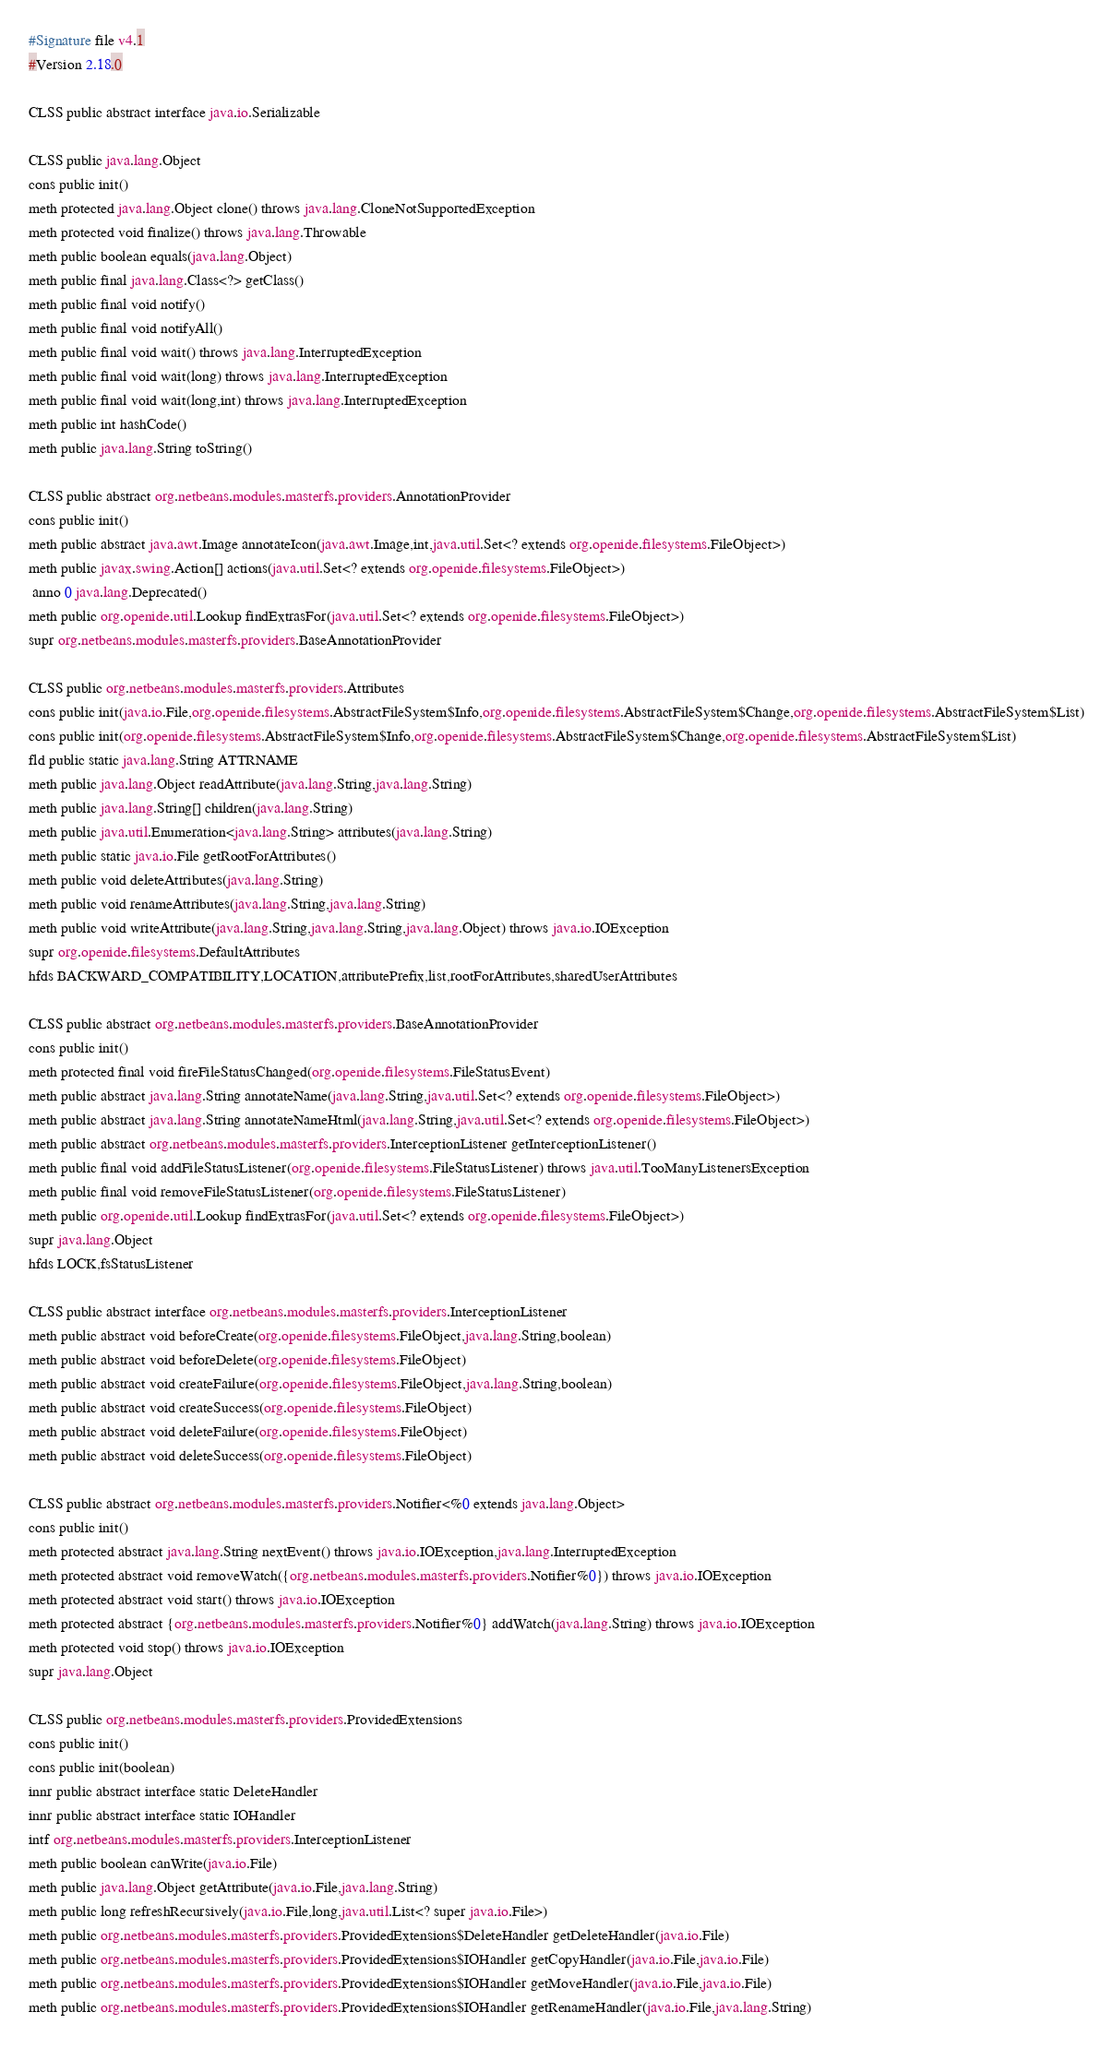<code> <loc_0><loc_0><loc_500><loc_500><_SML_>#Signature file v4.1
#Version 2.18.0

CLSS public abstract interface java.io.Serializable

CLSS public java.lang.Object
cons public init()
meth protected java.lang.Object clone() throws java.lang.CloneNotSupportedException
meth protected void finalize() throws java.lang.Throwable
meth public boolean equals(java.lang.Object)
meth public final java.lang.Class<?> getClass()
meth public final void notify()
meth public final void notifyAll()
meth public final void wait() throws java.lang.InterruptedException
meth public final void wait(long) throws java.lang.InterruptedException
meth public final void wait(long,int) throws java.lang.InterruptedException
meth public int hashCode()
meth public java.lang.String toString()

CLSS public abstract org.netbeans.modules.masterfs.providers.AnnotationProvider
cons public init()
meth public abstract java.awt.Image annotateIcon(java.awt.Image,int,java.util.Set<? extends org.openide.filesystems.FileObject>)
meth public javax.swing.Action[] actions(java.util.Set<? extends org.openide.filesystems.FileObject>)
 anno 0 java.lang.Deprecated()
meth public org.openide.util.Lookup findExtrasFor(java.util.Set<? extends org.openide.filesystems.FileObject>)
supr org.netbeans.modules.masterfs.providers.BaseAnnotationProvider

CLSS public org.netbeans.modules.masterfs.providers.Attributes
cons public init(java.io.File,org.openide.filesystems.AbstractFileSystem$Info,org.openide.filesystems.AbstractFileSystem$Change,org.openide.filesystems.AbstractFileSystem$List)
cons public init(org.openide.filesystems.AbstractFileSystem$Info,org.openide.filesystems.AbstractFileSystem$Change,org.openide.filesystems.AbstractFileSystem$List)
fld public static java.lang.String ATTRNAME
meth public java.lang.Object readAttribute(java.lang.String,java.lang.String)
meth public java.lang.String[] children(java.lang.String)
meth public java.util.Enumeration<java.lang.String> attributes(java.lang.String)
meth public static java.io.File getRootForAttributes()
meth public void deleteAttributes(java.lang.String)
meth public void renameAttributes(java.lang.String,java.lang.String)
meth public void writeAttribute(java.lang.String,java.lang.String,java.lang.Object) throws java.io.IOException
supr org.openide.filesystems.DefaultAttributes
hfds BACKWARD_COMPATIBILITY,LOCATION,attributePrefix,list,rootForAttributes,sharedUserAttributes

CLSS public abstract org.netbeans.modules.masterfs.providers.BaseAnnotationProvider
cons public init()
meth protected final void fireFileStatusChanged(org.openide.filesystems.FileStatusEvent)
meth public abstract java.lang.String annotateName(java.lang.String,java.util.Set<? extends org.openide.filesystems.FileObject>)
meth public abstract java.lang.String annotateNameHtml(java.lang.String,java.util.Set<? extends org.openide.filesystems.FileObject>)
meth public abstract org.netbeans.modules.masterfs.providers.InterceptionListener getInterceptionListener()
meth public final void addFileStatusListener(org.openide.filesystems.FileStatusListener) throws java.util.TooManyListenersException
meth public final void removeFileStatusListener(org.openide.filesystems.FileStatusListener)
meth public org.openide.util.Lookup findExtrasFor(java.util.Set<? extends org.openide.filesystems.FileObject>)
supr java.lang.Object
hfds LOCK,fsStatusListener

CLSS public abstract interface org.netbeans.modules.masterfs.providers.InterceptionListener
meth public abstract void beforeCreate(org.openide.filesystems.FileObject,java.lang.String,boolean)
meth public abstract void beforeDelete(org.openide.filesystems.FileObject)
meth public abstract void createFailure(org.openide.filesystems.FileObject,java.lang.String,boolean)
meth public abstract void createSuccess(org.openide.filesystems.FileObject)
meth public abstract void deleteFailure(org.openide.filesystems.FileObject)
meth public abstract void deleteSuccess(org.openide.filesystems.FileObject)

CLSS public abstract org.netbeans.modules.masterfs.providers.Notifier<%0 extends java.lang.Object>
cons public init()
meth protected abstract java.lang.String nextEvent() throws java.io.IOException,java.lang.InterruptedException
meth protected abstract void removeWatch({org.netbeans.modules.masterfs.providers.Notifier%0}) throws java.io.IOException
meth protected abstract void start() throws java.io.IOException
meth protected abstract {org.netbeans.modules.masterfs.providers.Notifier%0} addWatch(java.lang.String) throws java.io.IOException
meth protected void stop() throws java.io.IOException
supr java.lang.Object

CLSS public org.netbeans.modules.masterfs.providers.ProvidedExtensions
cons public init()
cons public init(boolean)
innr public abstract interface static DeleteHandler
innr public abstract interface static IOHandler
intf org.netbeans.modules.masterfs.providers.InterceptionListener
meth public boolean canWrite(java.io.File)
meth public java.lang.Object getAttribute(java.io.File,java.lang.String)
meth public long refreshRecursively(java.io.File,long,java.util.List<? super java.io.File>)
meth public org.netbeans.modules.masterfs.providers.ProvidedExtensions$DeleteHandler getDeleteHandler(java.io.File)
meth public org.netbeans.modules.masterfs.providers.ProvidedExtensions$IOHandler getCopyHandler(java.io.File,java.io.File)
meth public org.netbeans.modules.masterfs.providers.ProvidedExtensions$IOHandler getMoveHandler(java.io.File,java.io.File)
meth public org.netbeans.modules.masterfs.providers.ProvidedExtensions$IOHandler getRenameHandler(java.io.File,java.lang.String)</code> 